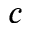<formula> <loc_0><loc_0><loc_500><loc_500>c</formula> 